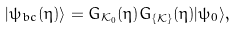<formula> <loc_0><loc_0><loc_500><loc_500>| \psi _ { b c } ( \eta ) \rangle = G _ { { \mathcal { K } } _ { 0 } } ( \eta ) G _ { \left \{ { \mathcal { K } } \right \} } ( \eta ) | \psi _ { 0 } \rangle ,</formula> 